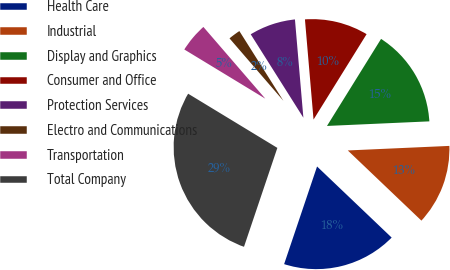<chart> <loc_0><loc_0><loc_500><loc_500><pie_chart><fcel>Health Care<fcel>Industrial<fcel>Display and Graphics<fcel>Consumer and Office<fcel>Protection Services<fcel>Electro and Communications<fcel>Transportation<fcel>Total Company<nl><fcel>18.06%<fcel>12.83%<fcel>15.44%<fcel>10.21%<fcel>7.6%<fcel>2.37%<fcel>4.98%<fcel>28.51%<nl></chart> 